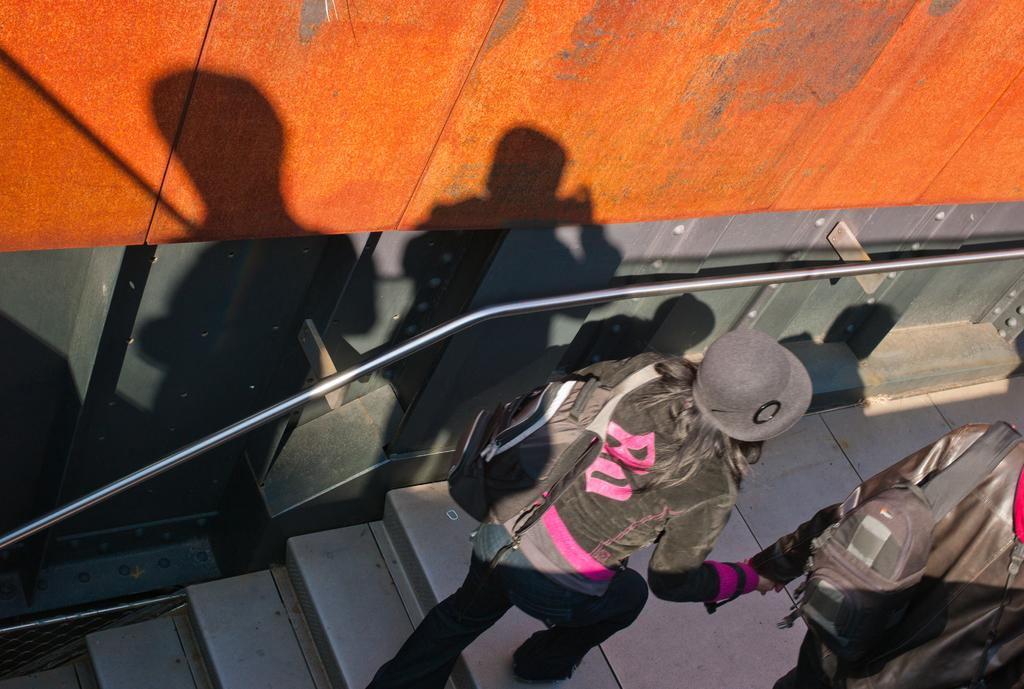How many people are in the image? There are two people in the image. What are the people doing in the image? The people are walking and carrying bags. What can be seen in the background of the image? There are steps and a rod in the image. What else is visible in the image besides the people and the steps? Shadows of the people are visible on a wall. What type of nut is being cracked by the elbow in the image? There is no nut or elbow present in the image. How much dirt can be seen on the shoes of the people in the image? The image does not provide information about the cleanliness of the people's shoes, so it cannot be determined from the image. 